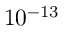<formula> <loc_0><loc_0><loc_500><loc_500>1 0 ^ { - 1 3 }</formula> 